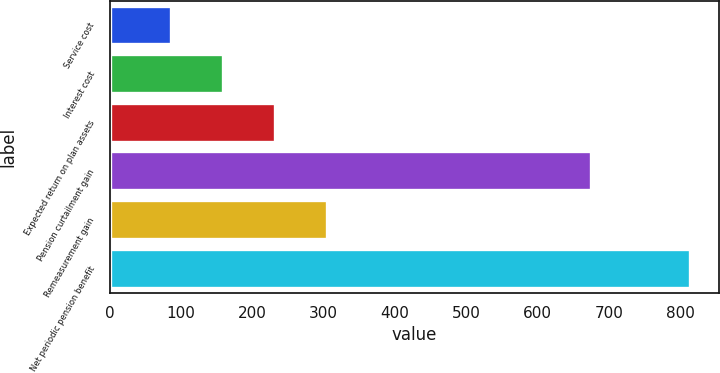Convert chart. <chart><loc_0><loc_0><loc_500><loc_500><bar_chart><fcel>Service cost<fcel>Interest cost<fcel>Expected return on plan assets<fcel>Pension curtailment gain<fcel>Remeasurement gain<fcel>Net periodic pension benefit<nl><fcel>86<fcel>158.7<fcel>231.4<fcel>675<fcel>304.1<fcel>813<nl></chart> 